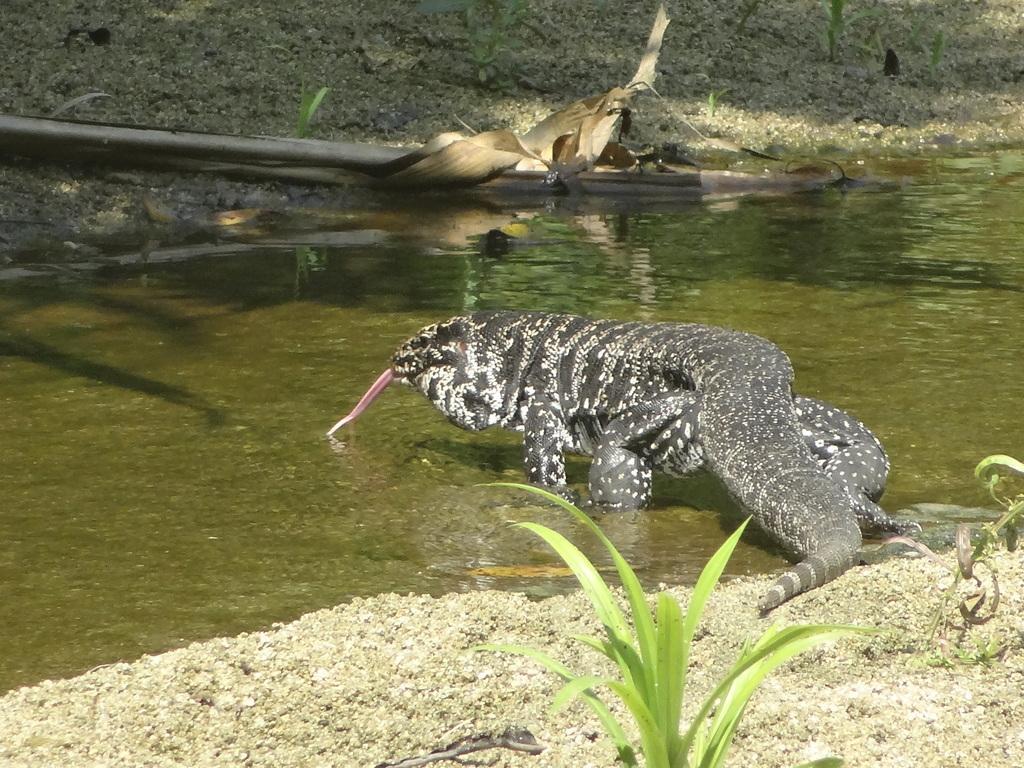Please provide a concise description of this image. In the center of the image we can see a Komodo Dragon in the water. At the bottom of the image we can see the plants and ground. At the top of the image we can see the stick, plants and ground. 